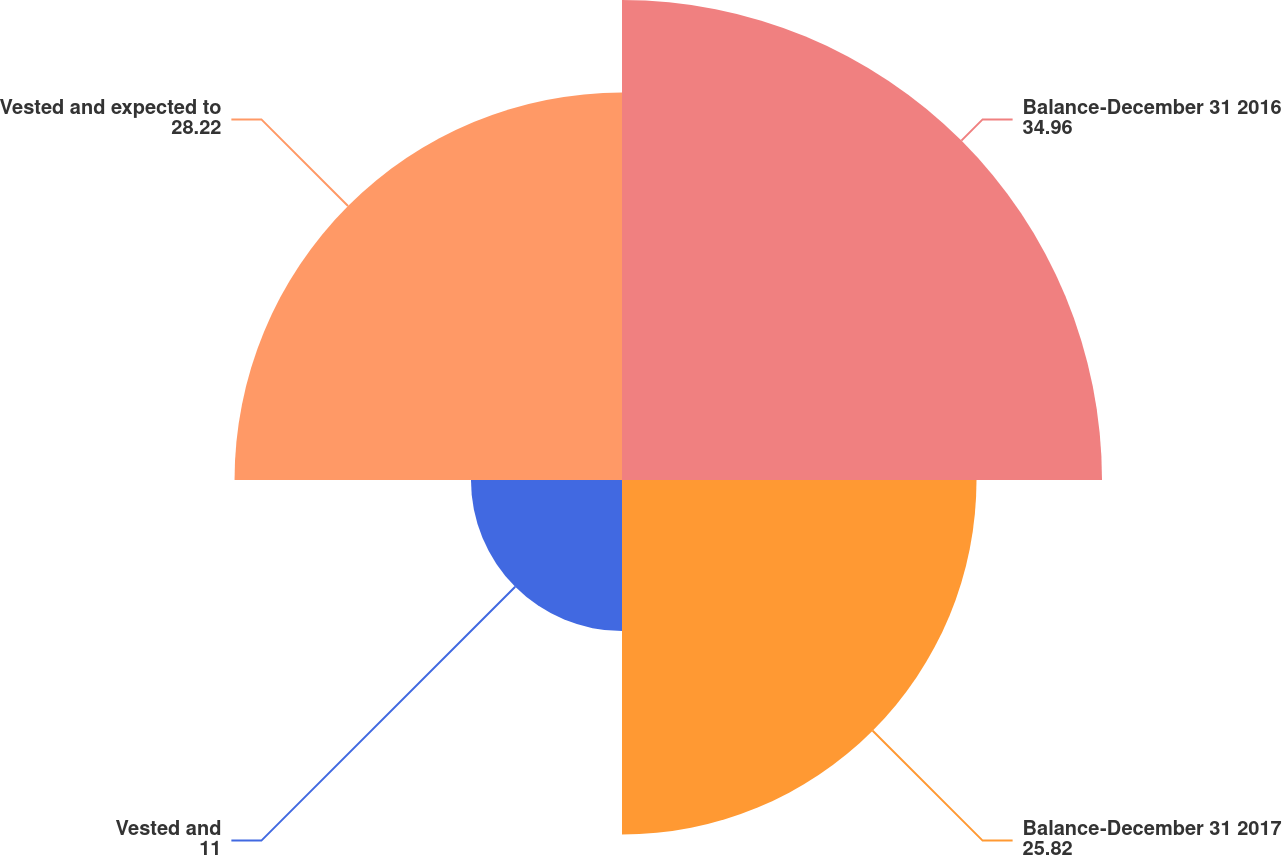Convert chart to OTSL. <chart><loc_0><loc_0><loc_500><loc_500><pie_chart><fcel>Balance-December 31 2016<fcel>Balance-December 31 2017<fcel>Vested and<fcel>Vested and expected to<nl><fcel>34.96%<fcel>25.82%<fcel>11.0%<fcel>28.22%<nl></chart> 